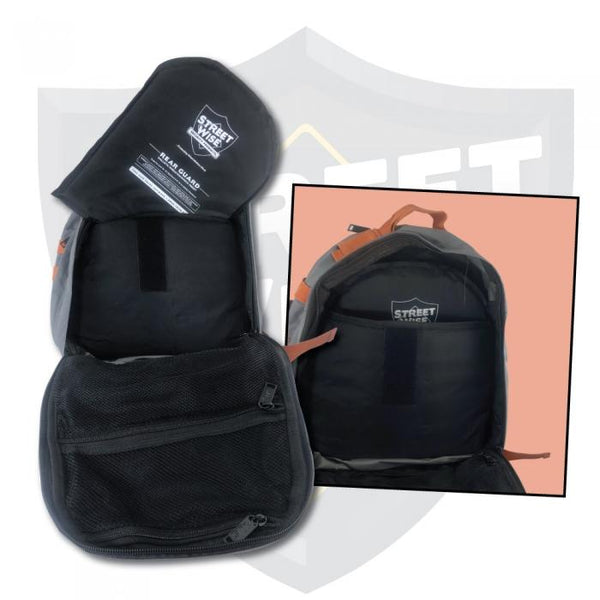Could you describe an everyday scenario where a student might find this backpack useful? Absolutely! A student could find this backpack incredibly useful for their daily campus life. With plenty of compartments, they can organize their books, laptop, and stationery efficiently. The ventilated mesh pocket would be perfect for keeping a gym outfit or lunch box separate from academic materials. Reflective elements improve their visibility during early morning or late evening commutes, ensuring safety if they walk or ride a bike to school. After a long day of classes, they can easily stash away their sports equipment or extra layers of clothing neatly, thanks to the ample and well-structured storage space within the backpack. 